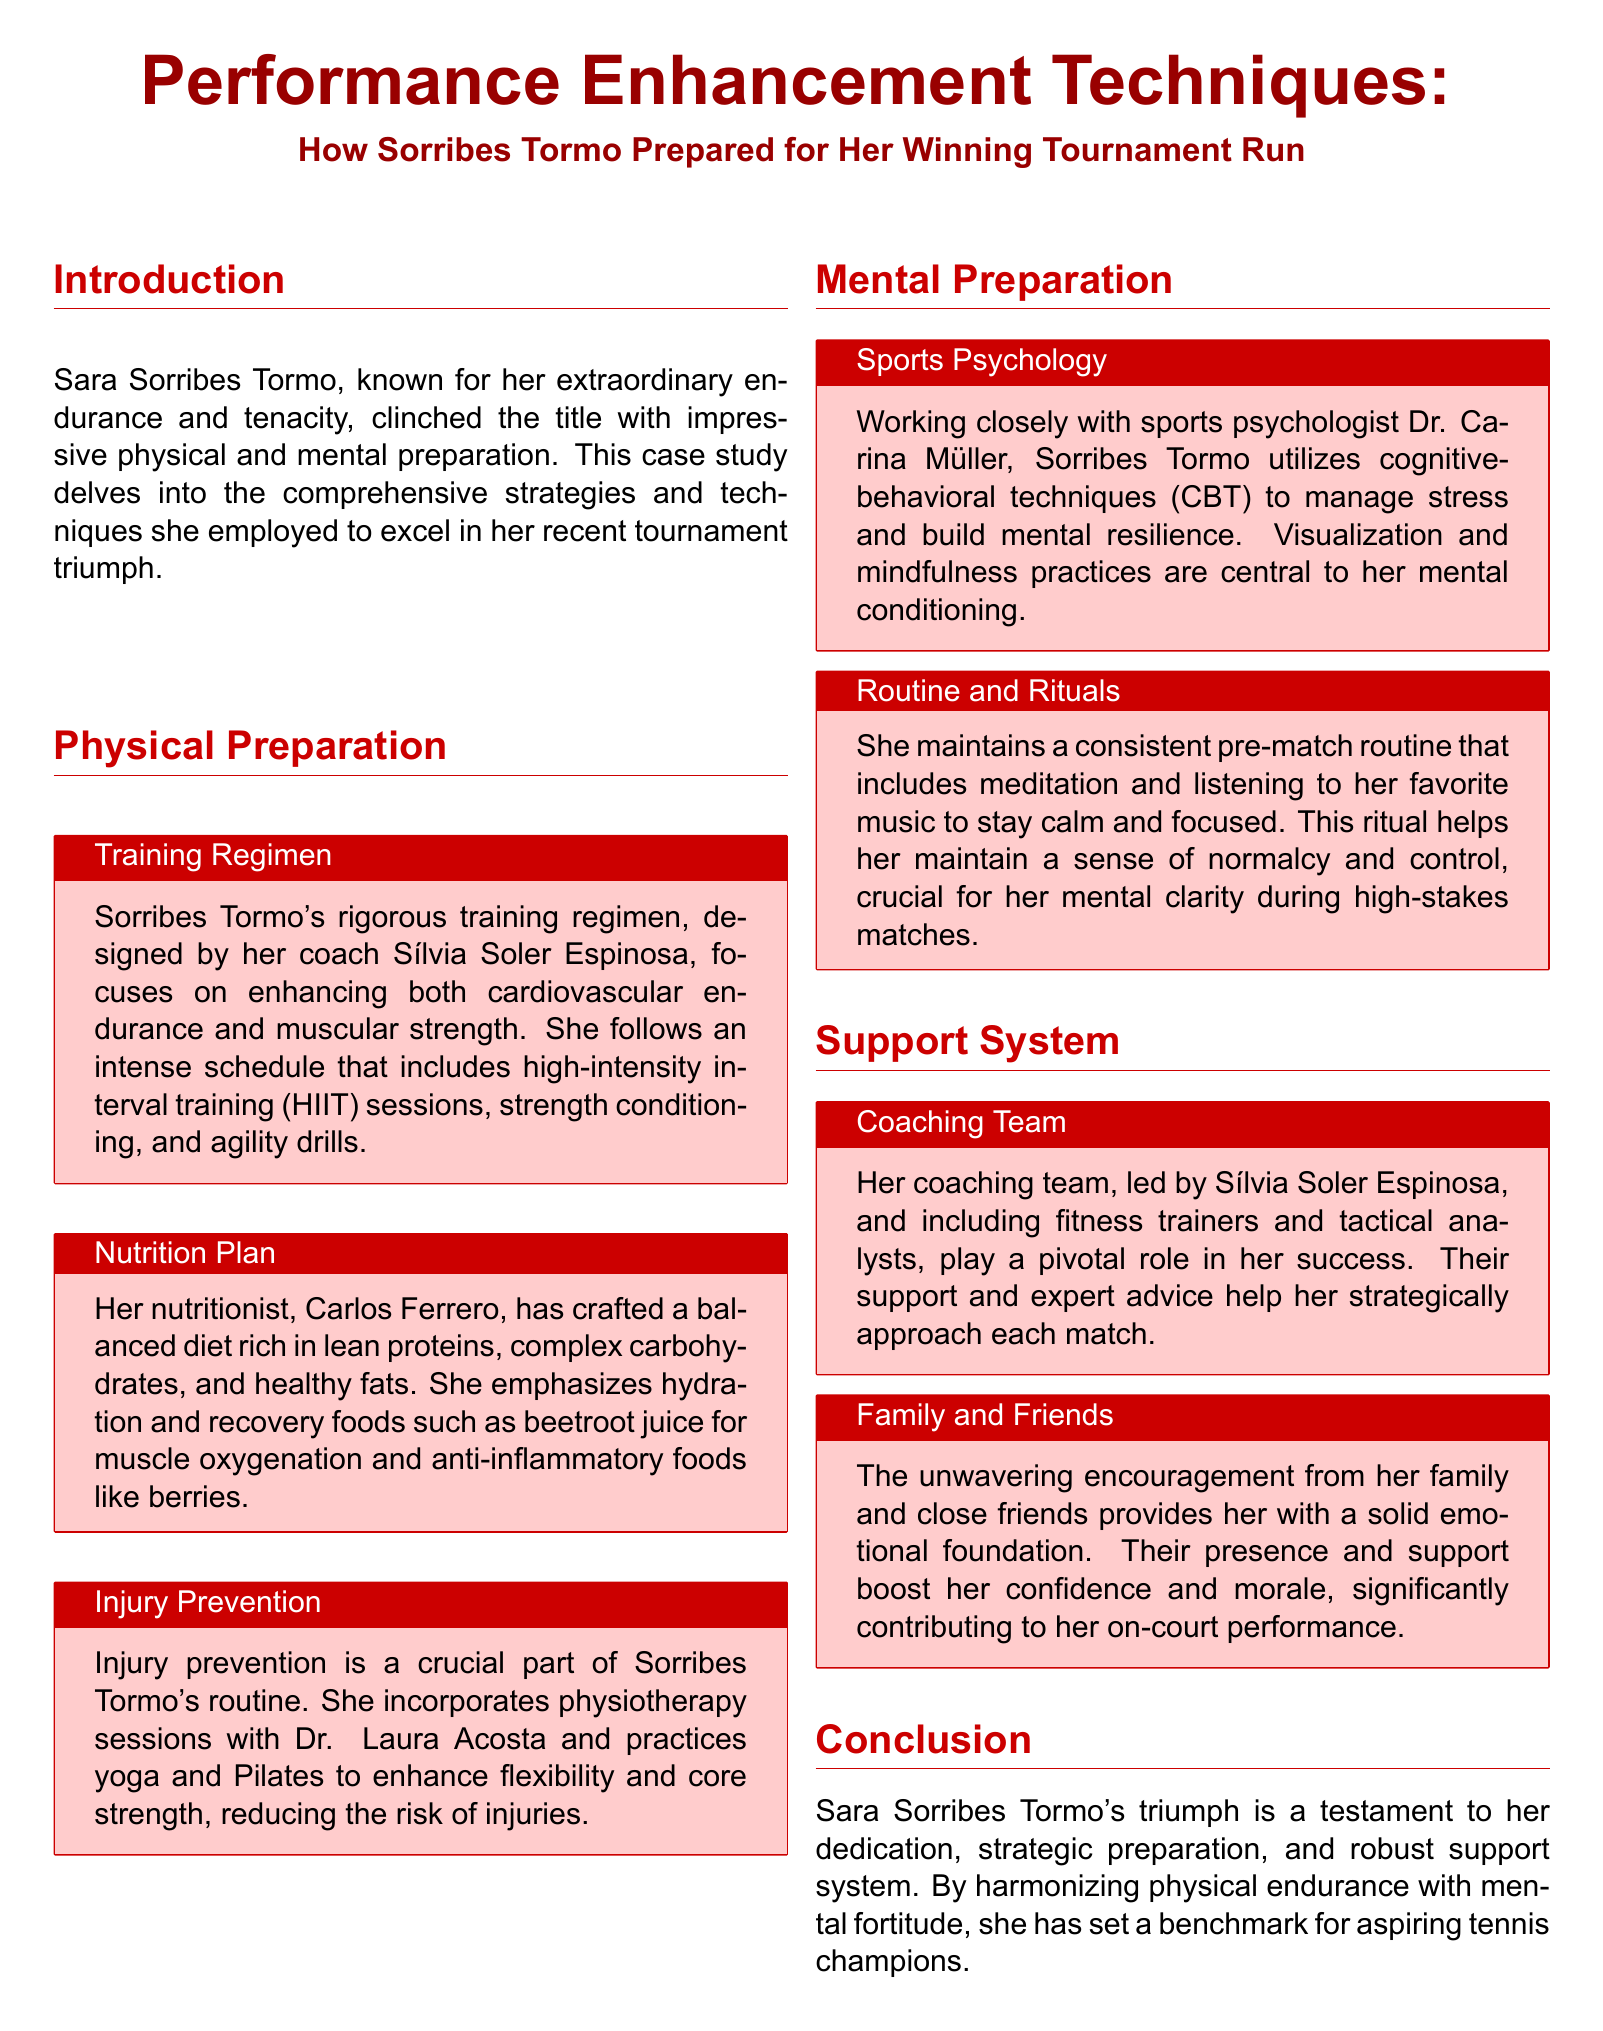What is Sara Sorribes Tormo known for? The document states that Sorribes Tormo is known for her extraordinary endurance and tenacity.
Answer: extraordinary endurance and tenacity Who designed Sorribes Tormo's training regimen? The training regimen was designed by her coach Sílvia Soler Espinosa.
Answer: Sílvia Soler Espinosa What kind of training does Sorribes Tormo include in her regimen? The training includes high-intensity interval training (HIIT) sessions, strength conditioning, and agility drills.
Answer: high-intensity interval training (HIIT), strength conditioning, and agility drills What type of techniques does Dr. Carina Müller use with Sorribes Tormo? Dr. Müller utilizes cognitive-behavioral techniques (CBT) to manage stress and build mental resilience.
Answer: cognitive-behavioral techniques (CBT) What does Sorribes Tormo consume for muscle oxygenation? Sorribes Tormo emphasizes recovery foods such as beetroot juice for muscle oxygenation.
Answer: beetroot juice Who provides emotional support to Sorribes Tormo? The document mentions that her family and close friends provide emotional support.
Answer: family and close friends What is Sorribes Tormo's pre-match routine? Her pre-match routine includes meditation and listening to her favorite music to stay calm and focused.
Answer: meditation and listening to her favorite music What role does Sílvia Soler Espinosa play in Sorribes Tormo's success? Sílvia Soler Espinosa leads her coaching team, providing pivotal support and expert advice.
Answer: leads her coaching team What is the focus of Sorribes Tormo's diet? Her diet is focused on being rich in lean proteins, complex carbohydrates, and healthy fats.
Answer: lean proteins, complex carbohydrates, and healthy fats 